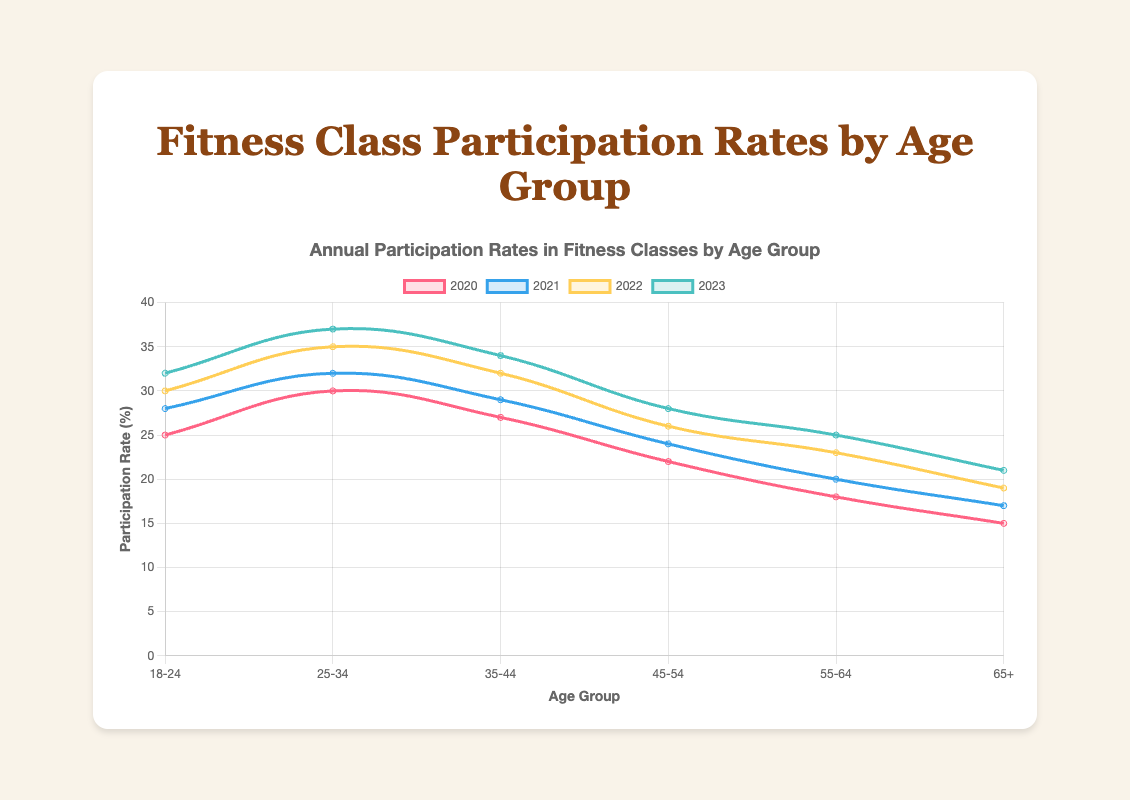Which age group showed the highest participation rate in 2023? To find the highest participation rate in 2023, look at the data points for each age group under the 2023 label. Compare them all. The age group 25-34 has the highest value of 37.
Answer: 25-34 Which year had the most significant increase in participation rate for the 35-44 age group? Examine the annual participation rates for the 35-44 age group. Calculate the differences between consecutive years: 2021-2020 (2), 2022-2021 (3), 2023-2022 (2). The most significant increase is from 2021 to 2022 with a difference of 3.
Answer: 2022 How much did the participation rate for the 55-64 age group increase from 2020 to 2023? Find the participation rate for the 55-64 age group in 2020 (18) and in 2023 (25). The increase can be found by subtracting 18 from 25.
Answer: 7 Which age group had the lowest participation rate in 2021? Compare the data points for each age group under the 2021 label. The age group 65+ has the lowest value of 17.
Answer: 65+ For the 18-24 age group, what is the average annual participation rate over the four years? The participation rates for 18-24 are 25, 28, 30, and 32. Sum these values to get 115, then divide by 4.
Answer: 28.75 What's the total participation rate in 2023 for all age groups combined? Sum the participation rates for all age groups in 2023: 32 + 37 + 34 + 28 + 25 + 21. This gives a total of 177.
Answer: 177 Which year shows the highest participation rate for the 45-54 age group? Compare the participation rates in the 45-54 age group across the years. The highest rate is in 2023 with a value of 28.
Answer: 2023 What's the difference in the participation rate between the 25-34 and 45-54 age groups in 2023? Subtract the participation rate of the 45-54 group (28) from the 25-34 group (37). This results in a difference of 9.
Answer: 9 Which year had the smallest increase overall in participation rates for the 65+ age group? Calculate the year-to-year increases for the 65+ group: 2021-2020 (2), 2022-2021 (2), 2023-2022 (2). All increases are equal, so there's no smallest increase.
Answer: Consistent Which age group has consistently increased its participation rate each year from 2020 to 2023? Check each age group, noting if their participation rates increase every consecutive year. All age groups show a consistent increase each year.
Answer: All 